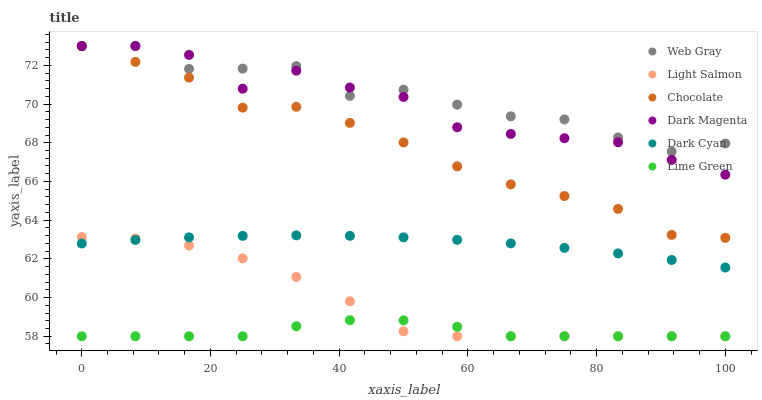Does Lime Green have the minimum area under the curve?
Answer yes or no. Yes. Does Web Gray have the maximum area under the curve?
Answer yes or no. Yes. Does Dark Magenta have the minimum area under the curve?
Answer yes or no. No. Does Dark Magenta have the maximum area under the curve?
Answer yes or no. No. Is Dark Cyan the smoothest?
Answer yes or no. Yes. Is Dark Magenta the roughest?
Answer yes or no. Yes. Is Web Gray the smoothest?
Answer yes or no. No. Is Web Gray the roughest?
Answer yes or no. No. Does Light Salmon have the lowest value?
Answer yes or no. Yes. Does Dark Magenta have the lowest value?
Answer yes or no. No. Does Chocolate have the highest value?
Answer yes or no. Yes. Does Dark Cyan have the highest value?
Answer yes or no. No. Is Light Salmon less than Chocolate?
Answer yes or no. Yes. Is Dark Magenta greater than Dark Cyan?
Answer yes or no. Yes. Does Dark Magenta intersect Web Gray?
Answer yes or no. Yes. Is Dark Magenta less than Web Gray?
Answer yes or no. No. Is Dark Magenta greater than Web Gray?
Answer yes or no. No. Does Light Salmon intersect Chocolate?
Answer yes or no. No. 